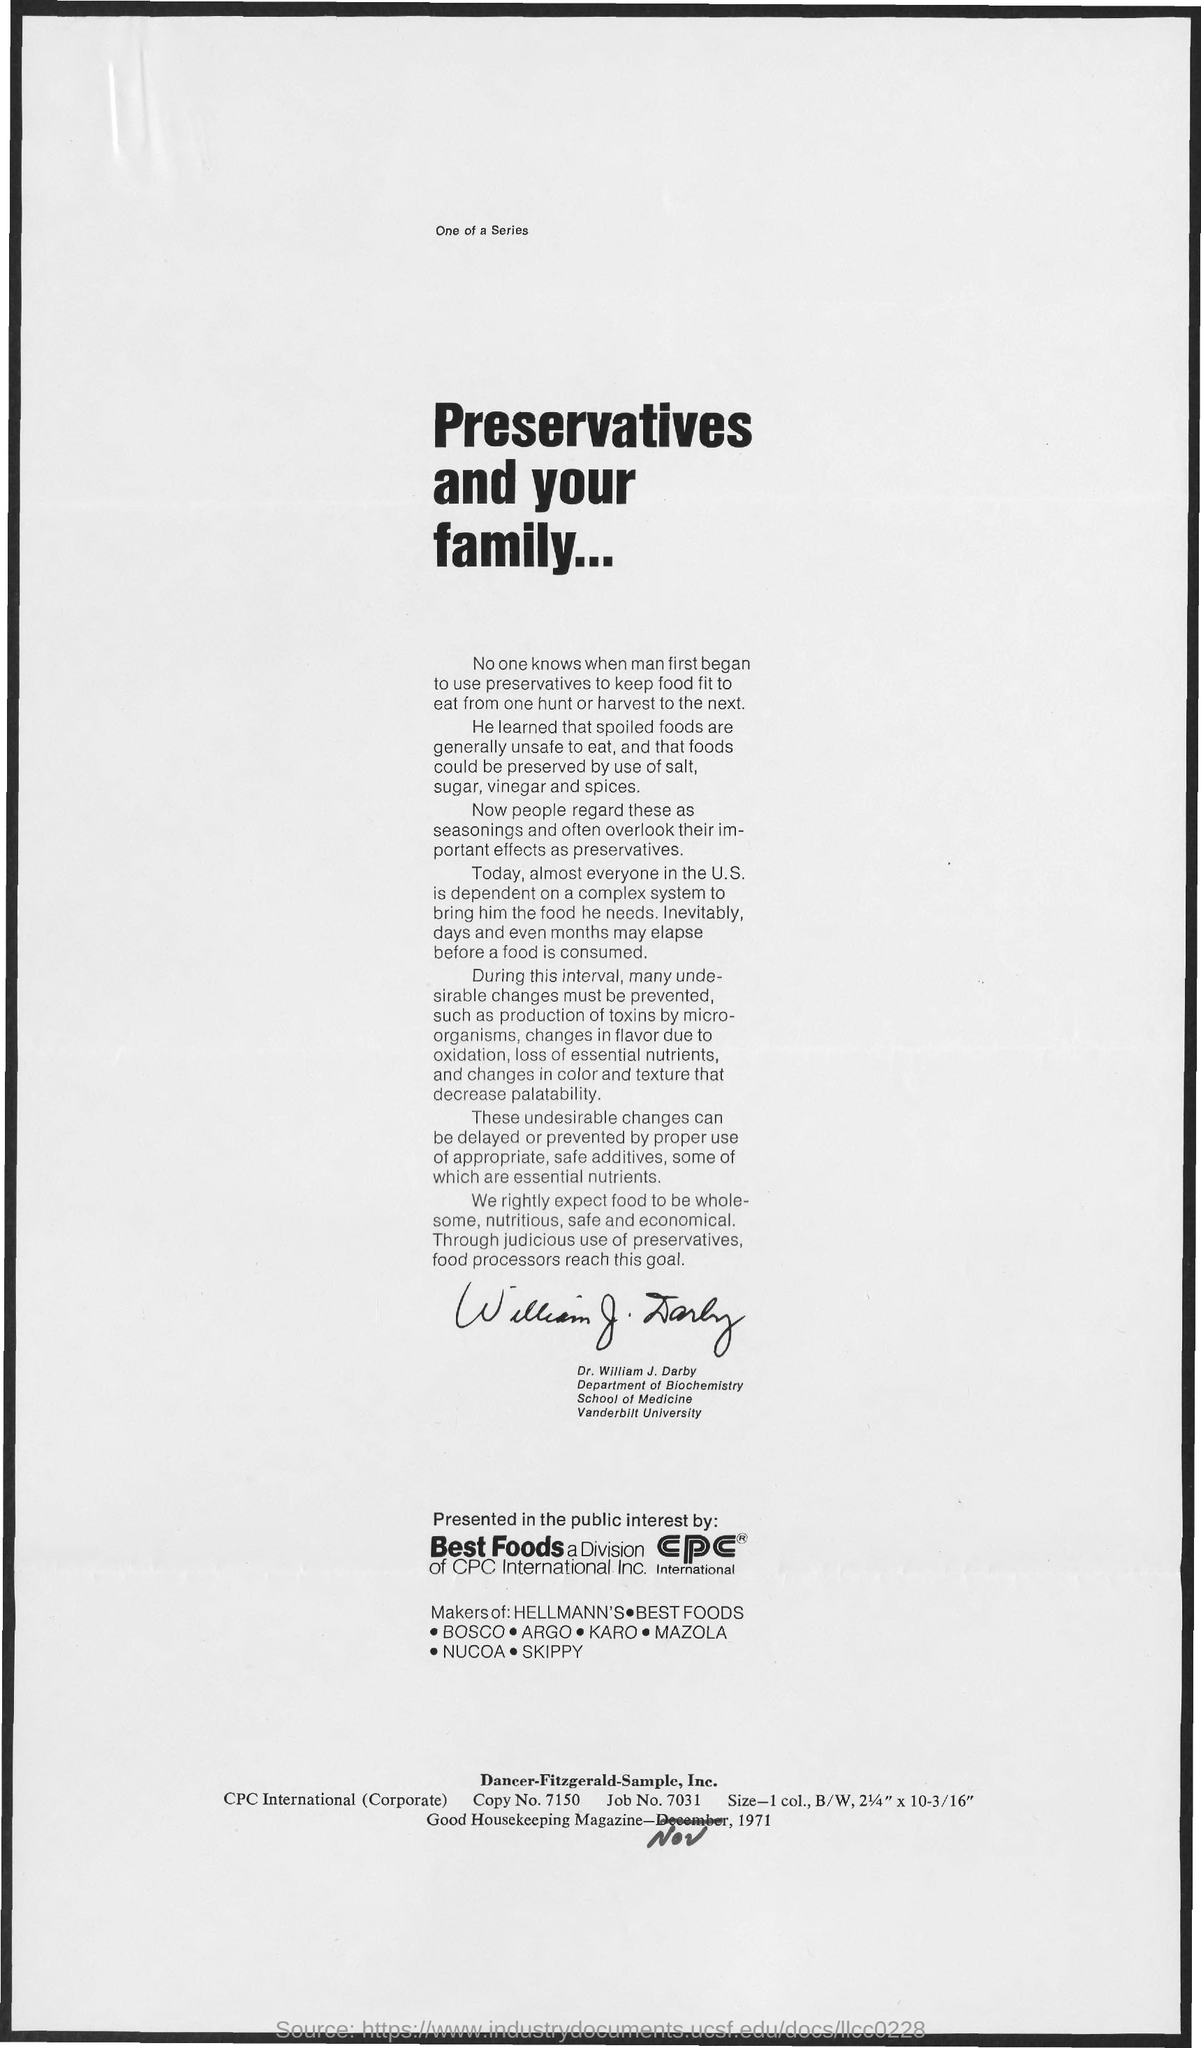Mention a couple of crucial points in this snapshot. The title of the document is 'Preservatives and Your Family.' 